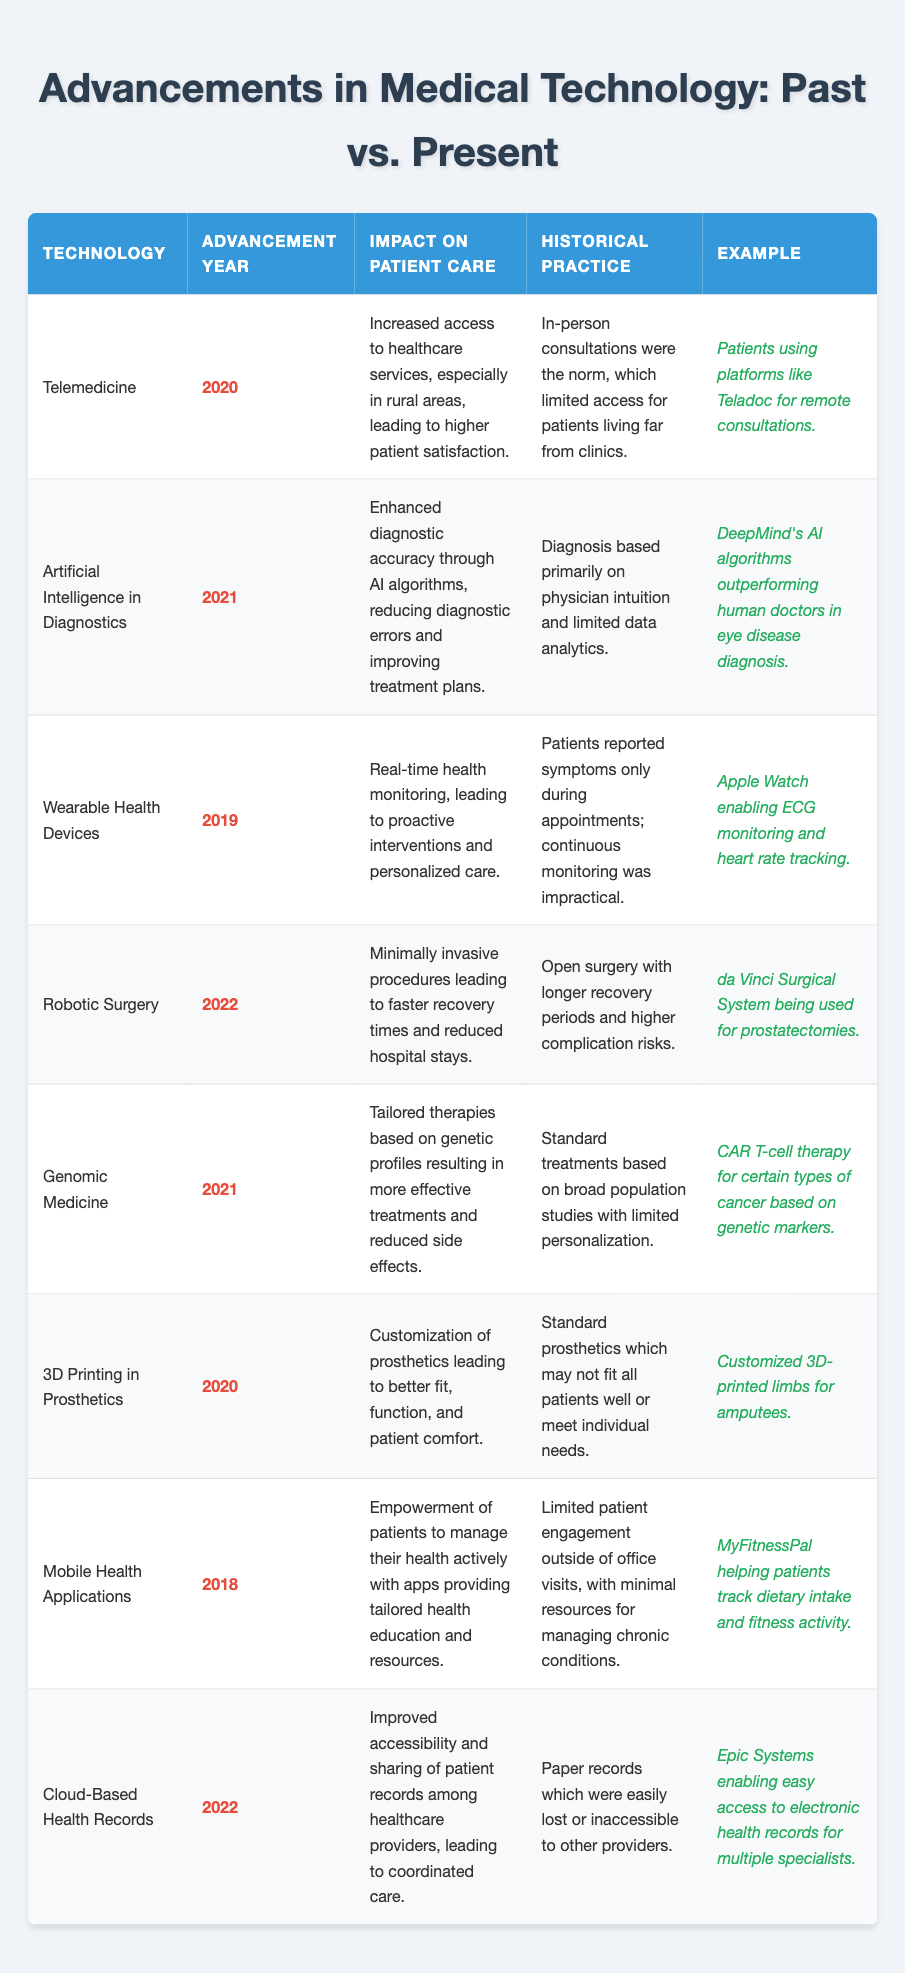What year was telemedicine advanced? The table lists "Telemedicine" under the "Technology" column, with "2020" noted in the "Advancement Year" column.
Answer: 2020 What is one impact of robotic surgery on patient care? Robotic surgery is noted to lead to "minimally invasive procedures," which are associated with "faster recovery times" in the corresponding column.
Answer: Faster recovery times What historical practice does genomic medicine contrast with? The historical practice mentioned for genomic medicine is "standard treatments based on broad population studies with limited personalization," as indicated in the table.
Answer: Standard treatments based on broad population studies Which technology was advanced in 2022? Looking through the "Advancement Year" column, both "Robotic Surgery" and "Cloud-Based Health Records" are listed with 2022 as the year.
Answer: Robotic Surgery and Cloud-Based Health Records Count how many technologies listed were advanced before 2020. The table shows that there are three technologies advanced before 2020: "Mobile Health Applications" (2018), "Wearable Health Devices" (2019), and "Telemedicine" (2020). Counting these gives a total of 2.
Answer: 2 Is it true that artificial intelligence has improved diagnostic accuracy? The table states "Enhanced diagnostic accuracy through AI algorithms" in the "Impact on Patient Care" column for artificial intelligence. Thus, it confirms the statement is true.
Answer: True What is the example given for wearable health devices? In the "Example" column for "Wearable Health Devices," it lists "Apple Watch enabling ECG monitoring and heart rate tracking" as the example.
Answer: Apple Watch enabling ECG monitoring What is the difference in patient care impact between 3D printing and historical prosthetics? 3D printing in prosthetics allows "customization...leading to better fit" compared to the historical practice of standard prosthetics which "may not fit all patients."
Answer: Better fit through customization What technology had its impact related to improving healthcare in rural areas? Telemedicine is associated with increased healthcare access in rural areas in the "Impact on Patient Care" column of the table.
Answer: Telemedicine How does the impact of mobile health applications empower patients? The table states that mobile health applications "empower patients to manage their health actively," indicating an active involvement in their healthcare, which was not emphasized in the historical practice.
Answer: Active health management by patients What are the two examples of technologies that enhance patient care through personalization? The technologies listed are "Genomic Medicine" for tailored therapies and "3D Printing in Prosthetics" for customization of prosthetics to individual needs according to the table.
Answer: Genomic Medicine and 3D Printing in Prosthetics What are the main advantages of cloud-based health records? The advantages noted are "improved accessibility and sharing of patient records among healthcare providers," leading to better-coordinated care. This reflects significant improvements over the historical practice of using paper records.
Answer: Improved accessibility and sharing of records 